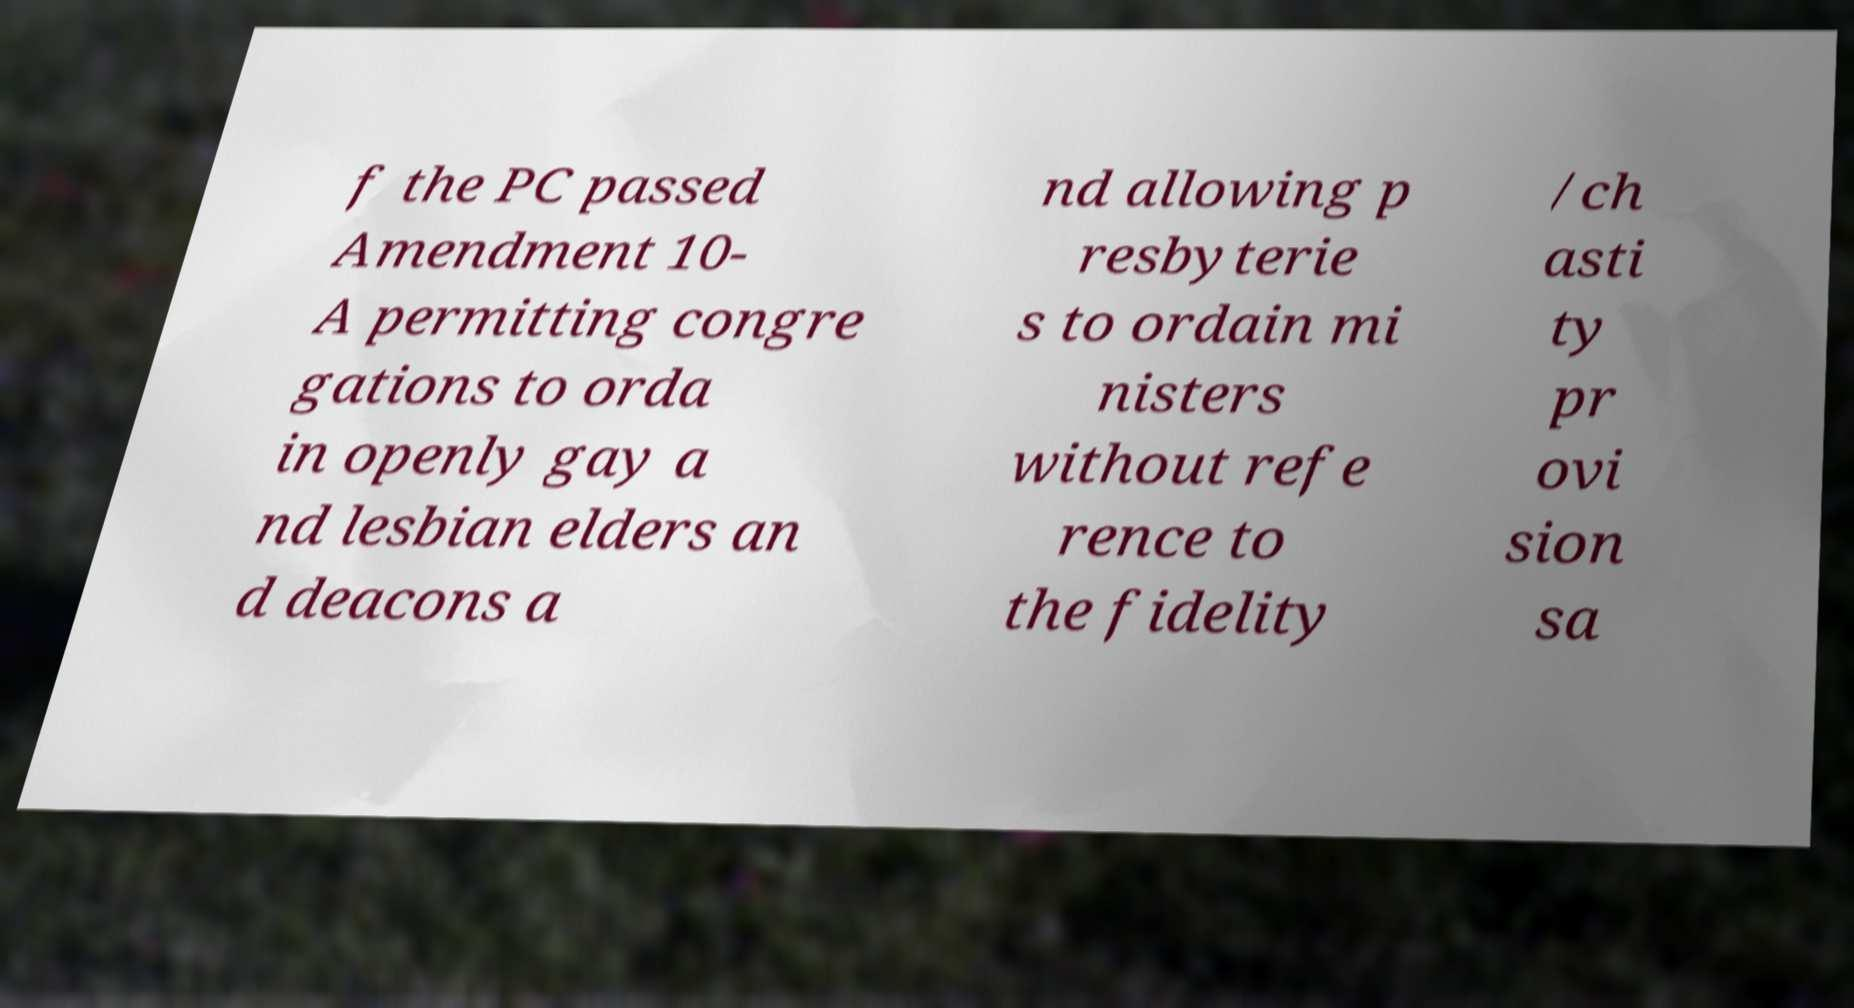Could you extract and type out the text from this image? f the PC passed Amendment 10- A permitting congre gations to orda in openly gay a nd lesbian elders an d deacons a nd allowing p resbyterie s to ordain mi nisters without refe rence to the fidelity /ch asti ty pr ovi sion sa 